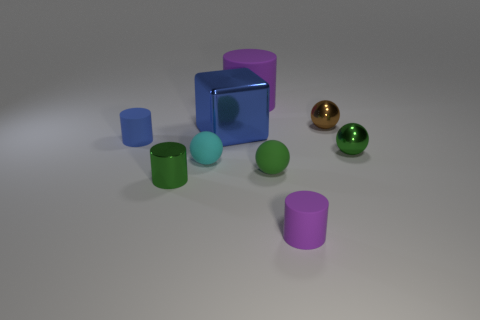What can you infer about the surface the objects are on? The surface appears to be smooth, with a slight reflective quality, indicating it could be made of a polished material. There's a subtle gradient in the lighting, which suggests it may be under artificial lighting conditions. Does it appear to be an indoor or outdoor setting? Given the controlled lighting and the lack of natural elements, it most likely depicts an indoor setting, possibly staged for a photograph or rendering. 